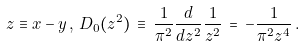<formula> <loc_0><loc_0><loc_500><loc_500>z \equiv x - y \, , \, D _ { 0 } ( z ^ { 2 } ) \, \equiv \, \frac { 1 } { \pi ^ { 2 } } \frac { d } { d z ^ { 2 } } \frac { 1 } { z ^ { 2 } } \, = \, - \frac { 1 } { \pi ^ { 2 } z ^ { 4 } } \, .</formula> 